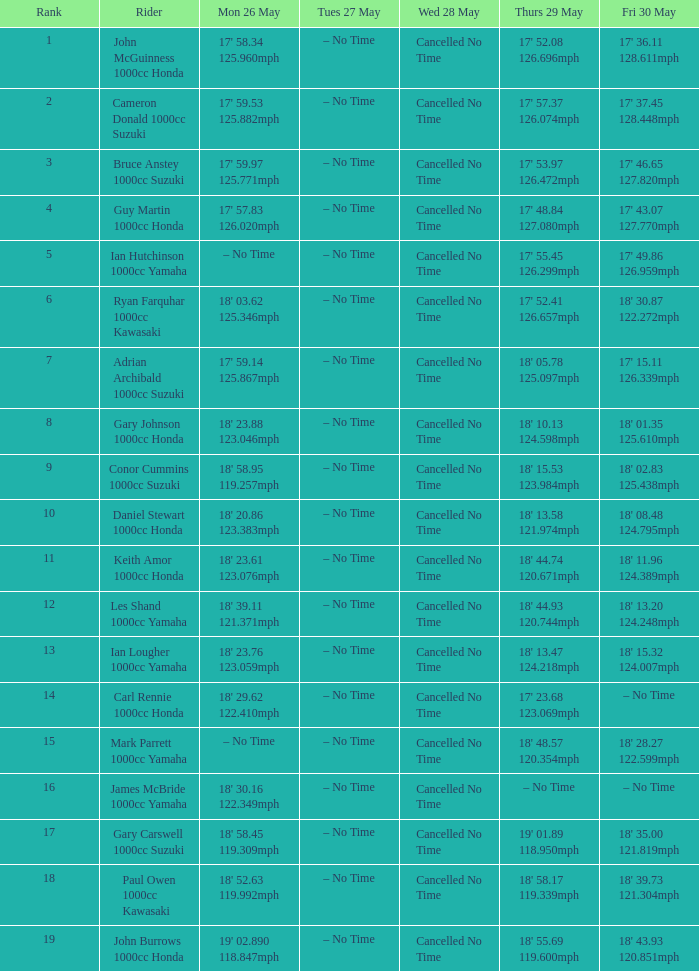What number corresponds to friday, may 30, and monday, may 26, when considering the figures 19' 02.890 and 118.847 mph? 18' 43.93 120.851mph. 